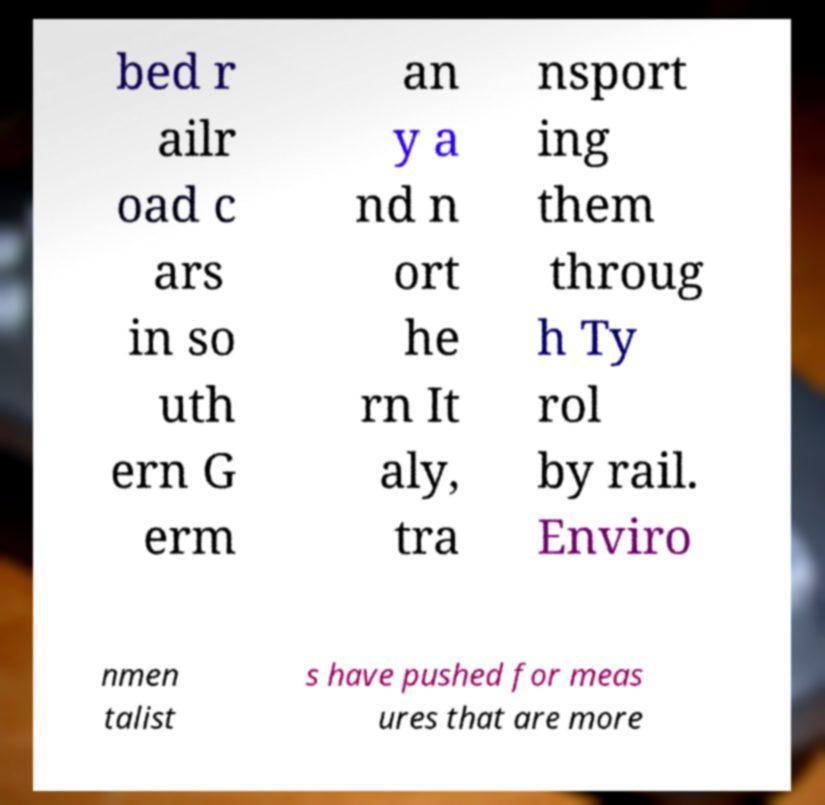I need the written content from this picture converted into text. Can you do that? bed r ailr oad c ars in so uth ern G erm an y a nd n ort he rn It aly, tra nsport ing them throug h Ty rol by rail. Enviro nmen talist s have pushed for meas ures that are more 